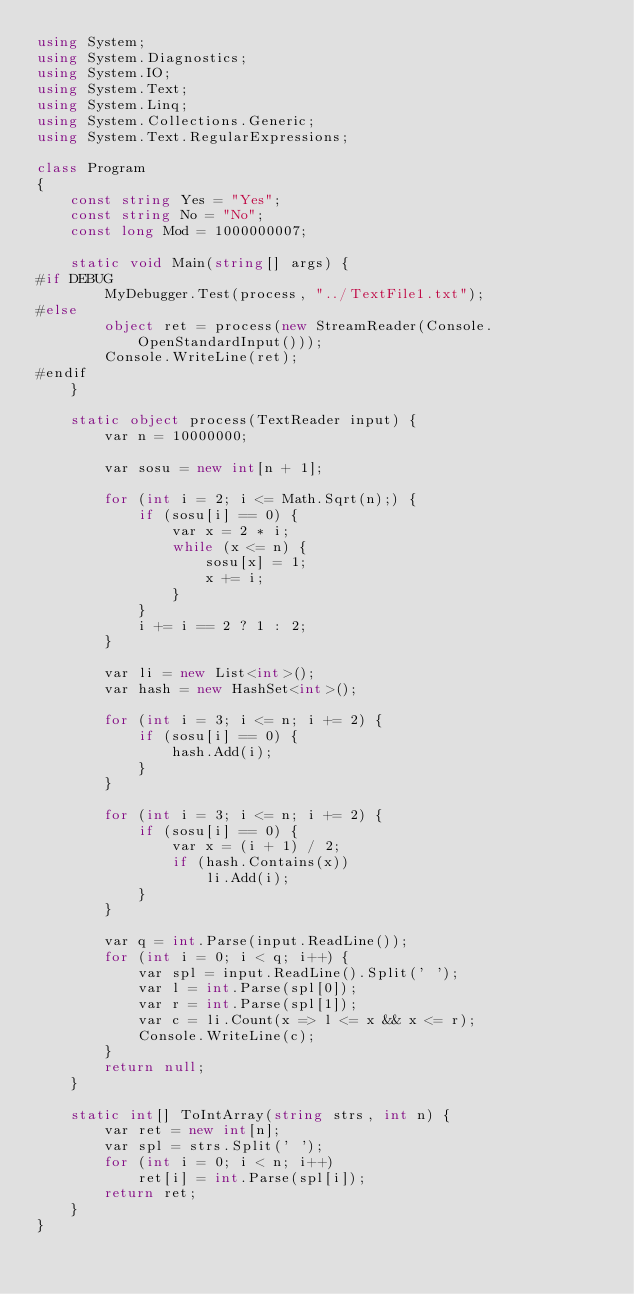<code> <loc_0><loc_0><loc_500><loc_500><_C#_>using System;
using System.Diagnostics;
using System.IO;
using System.Text;
using System.Linq;
using System.Collections.Generic;
using System.Text.RegularExpressions;

class Program
{
    const string Yes = "Yes";
    const string No = "No";
    const long Mod = 1000000007;

    static void Main(string[] args) {
#if DEBUG
        MyDebugger.Test(process, "../TextFile1.txt");
#else
        object ret = process(new StreamReader(Console.OpenStandardInput()));
        Console.WriteLine(ret);
#endif
    }

    static object process(TextReader input) {
        var n = 10000000;

        var sosu = new int[n + 1];

        for (int i = 2; i <= Math.Sqrt(n);) {
            if (sosu[i] == 0) {
                var x = 2 * i;
                while (x <= n) {
                    sosu[x] = 1;
                    x += i;
                }
            }
            i += i == 2 ? 1 : 2;
        }

        var li = new List<int>();
        var hash = new HashSet<int>();

        for (int i = 3; i <= n; i += 2) {
            if (sosu[i] == 0) {
                hash.Add(i);
            }
        }

        for (int i = 3; i <= n; i += 2) {
            if (sosu[i] == 0) {
                var x = (i + 1) / 2;
                if (hash.Contains(x))
                    li.Add(i);
            }
        }

        var q = int.Parse(input.ReadLine());
        for (int i = 0; i < q; i++) {
            var spl = input.ReadLine().Split(' ');
            var l = int.Parse(spl[0]);
            var r = int.Parse(spl[1]);
            var c = li.Count(x => l <= x && x <= r);
            Console.WriteLine(c);
        }
        return null;
    }

    static int[] ToIntArray(string strs, int n) {
        var ret = new int[n];
        var spl = strs.Split(' ');
        for (int i = 0; i < n; i++)
            ret[i] = int.Parse(spl[i]);
        return ret;
    }
}
</code> 